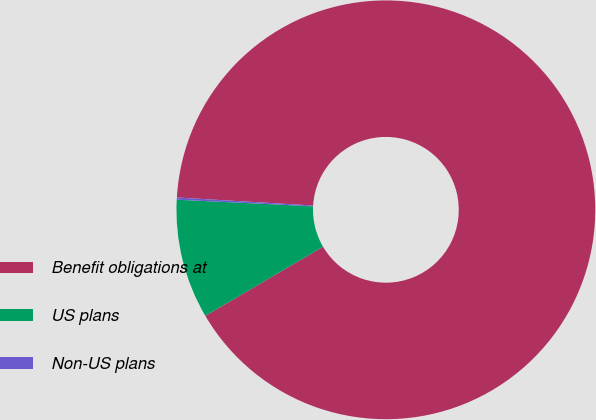<chart> <loc_0><loc_0><loc_500><loc_500><pie_chart><fcel>Benefit obligations at<fcel>US plans<fcel>Non-US plans<nl><fcel>90.61%<fcel>9.22%<fcel>0.17%<nl></chart> 